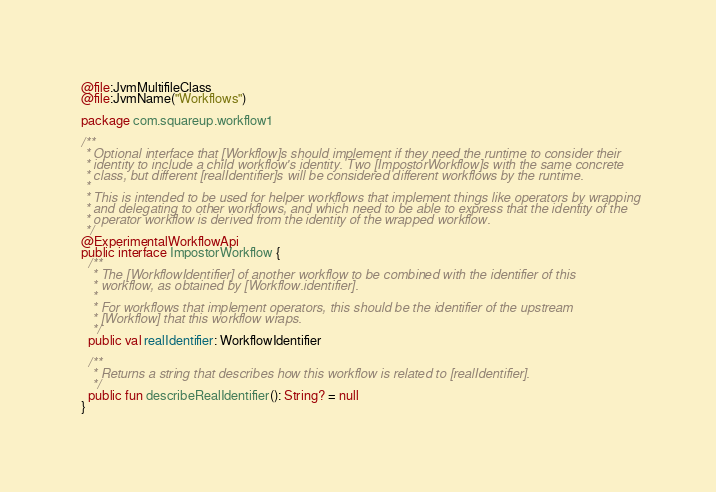Convert code to text. <code><loc_0><loc_0><loc_500><loc_500><_Kotlin_>@file:JvmMultifileClass
@file:JvmName("Workflows")

package com.squareup.workflow1

/**
 * Optional interface that [Workflow]s should implement if they need the runtime to consider their
 * identity to include a child workflow's identity. Two [ImpostorWorkflow]s with the same concrete
 * class, but different [realIdentifier]s will be considered different workflows by the runtime.
 *
 * This is intended to be used for helper workflows that implement things like operators by wrapping
 * and delegating to other workflows, and which need to be able to express that the identity of the
 * operator workflow is derived from the identity of the wrapped workflow.
 */
@ExperimentalWorkflowApi
public interface ImpostorWorkflow {
  /**
   * The [WorkflowIdentifier] of another workflow to be combined with the identifier of this
   * workflow, as obtained by [Workflow.identifier].
   *
   * For workflows that implement operators, this should be the identifier of the upstream
   * [Workflow] that this workflow wraps.
   */
  public val realIdentifier: WorkflowIdentifier

  /**
   * Returns a string that describes how this workflow is related to [realIdentifier].
   */
  public fun describeRealIdentifier(): String? = null
}
</code> 